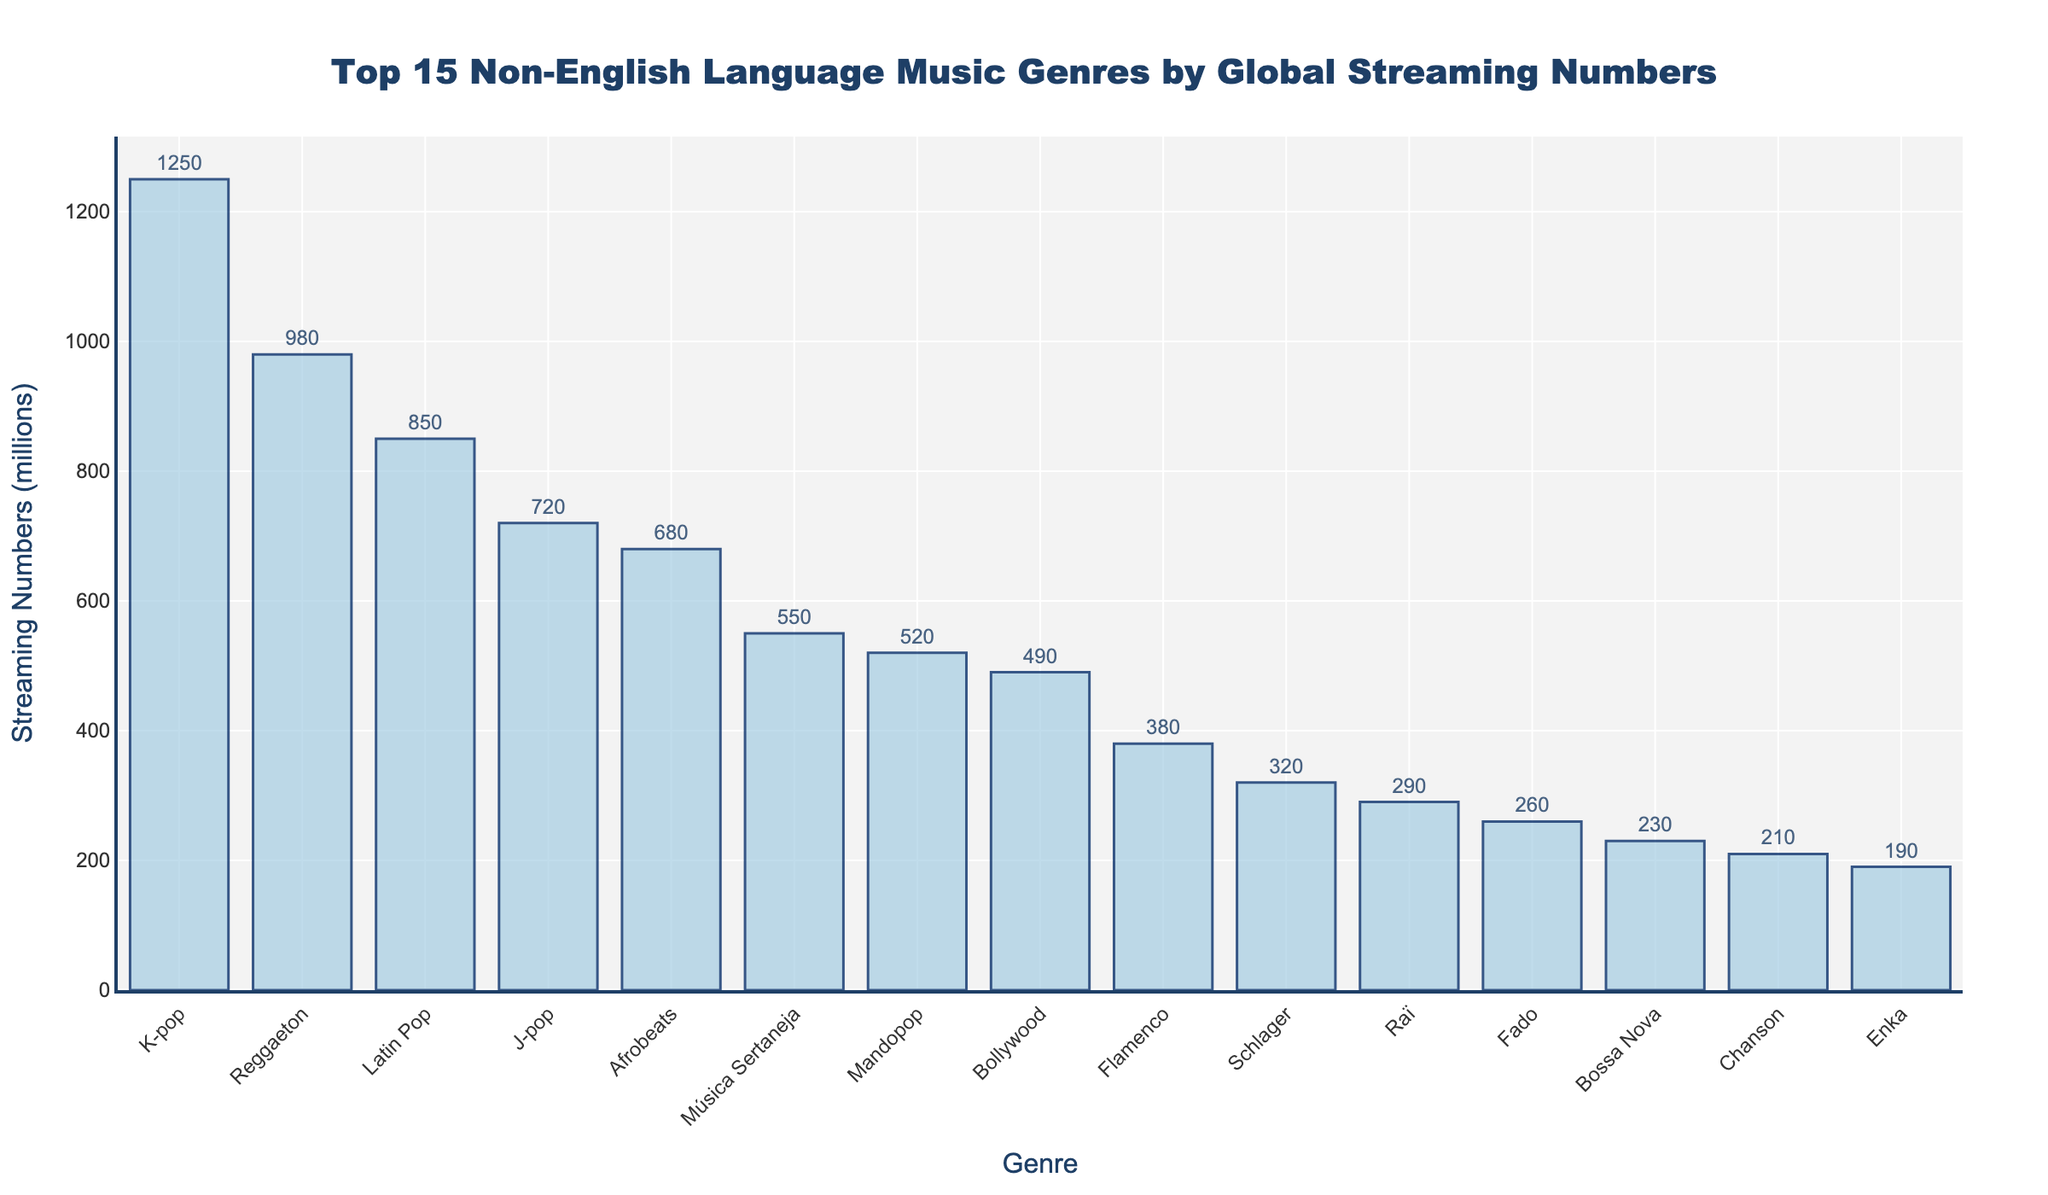What is the highest streaming genre? The highest streaming genre is identified by looking for the bar with the greatest height in the chart. The tallest bar represents K-pop.
Answer: K-pop Which genre has the lowest streaming numbers among the top 15? The lowest streaming genre among the top 15 is identified by finding the shortest bar in the chart, which represents Enka.
Answer: Enka How much higher are K-pop's streams compared to Reggaeton? To find out how much higher K-pop's streams are compared to Reggaeton, subtract Reggaeton's streaming numbers from K-pop's. K-pop has 1,250 million, and Reggaeton has 980 million streams. So, the difference is 1,250 - 980.
Answer: 270 million What genres have more than 500 million streams? To identify genres with more than 500 million streams, observe the bars that are taller than the point corresponding to 500 million on the y-axis. These genres are K-pop, Reggaeton, Latin Pop, J-pop, and Afrobeats.
Answer: K-pop, Reggaeton, Latin Pop, J-pop, Afrobeats Which genres fall into the middle range of streaming numbers between 200 million and 600 million? To find the genres in the middle range, locate the bars that fall between 200 million and 600 million on the y-axis. These genres are Afrobeats, Música Sertaneja, Mandopop, Bollywood, Flamenco, and Schlager.
Answer: Afrobeats, Música Sertaneja, Mandopop, Bollywood, Flamenco, Schlager Compare the number of streams in Latin Pop and J-pop. Which has more, and by how much? To compare the streams of Latin Pop and J-pop, observe the bars representing these genres. Latin Pop has 850 million streams, and J-pop has 720 million streams. Subtract J-pop's number from Latin Pop's to find the difference: 850 - 720.
Answer: Latin Pop by 130 million What is the combined total number of streams for Mandopop, Bollywood, and Flamenco? To find the combined streaming numbers, add the streams for Mandopop (520 million), Bollywood (490 million), and Flamenco (380 million). Thus, 520 + 490 + 380.
Answer: 1,390 million How much less are Schlager's streams compared to Música Sertaneja? Find the difference by subtracting Schlager's streaming numbers from Música Sertaneja's. Música Sertaneja has 550 million, and Schlager has 320 million streams. So, the difference is 550 - 320.
Answer: 230 million What is the average streaming number of the top 5 genres? To find the average streaming number of the top 5 genres, add their streaming numbers and divide by 5. The top 5 genres are K-pop (1,250 million), Reggaeton (980 million), Latin Pop (850 million), J-pop (720 million), and Afrobeats (680 million). The sum is 1,250 + 980 + 850 + 720 + 680, and the average is the sum divided by 5.
Answer: 896 million 